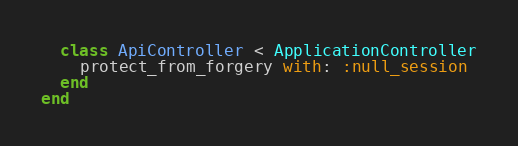Convert code to text. <code><loc_0><loc_0><loc_500><loc_500><_Ruby_>  class ApiController < ApplicationController
    protect_from_forgery with: :null_session
  end
end
</code> 